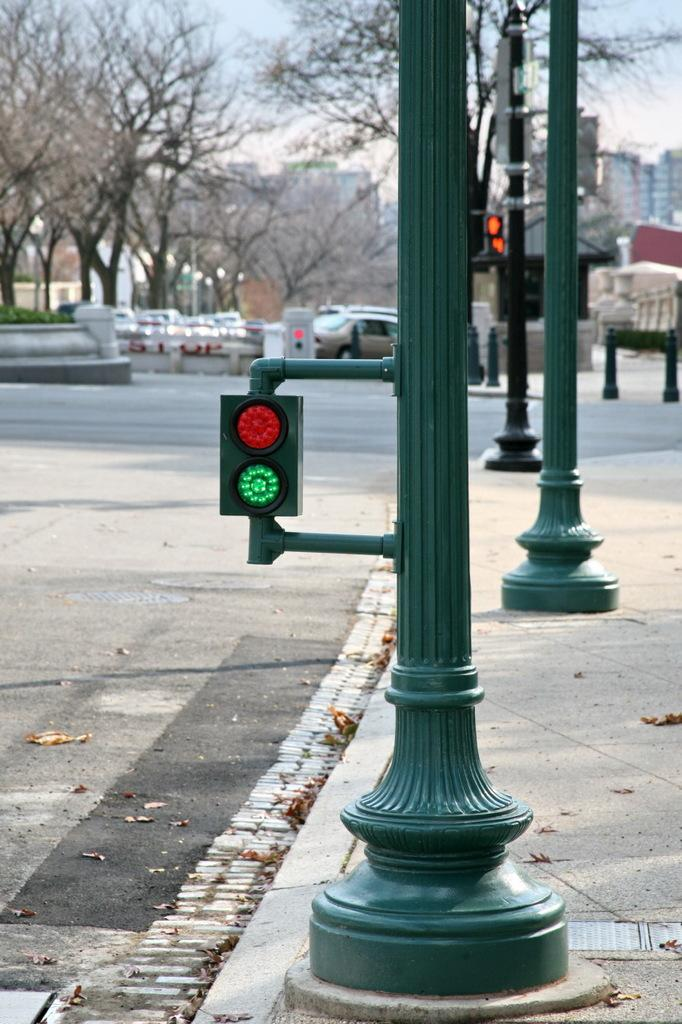What can be seen on the right side of the image? There are poles and lights on the right side of the image. What is visible in the background of the image? There are trees, vehicles, and buildings in the background of the image. What type of pipe is being expanded in the image? There is no pipe present in the image. How does the turn signal on the vehicle in the image function? There is no indication of a turn signal or vehicle function in the image. 